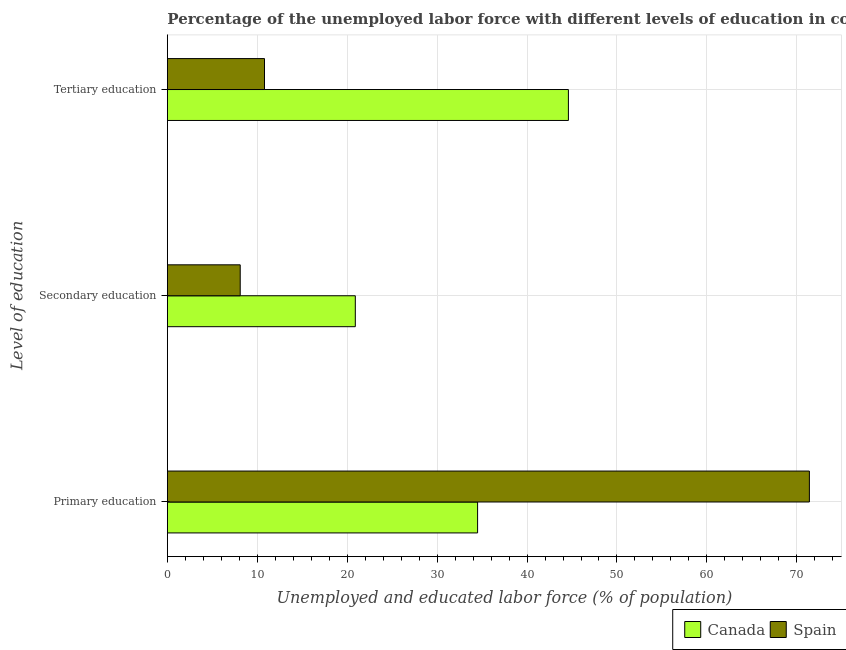Are the number of bars per tick equal to the number of legend labels?
Your answer should be compact. Yes. Are the number of bars on each tick of the Y-axis equal?
Provide a short and direct response. Yes. What is the label of the 2nd group of bars from the top?
Give a very brief answer. Secondary education. What is the percentage of labor force who received secondary education in Canada?
Your answer should be very brief. 20.9. Across all countries, what is the maximum percentage of labor force who received primary education?
Your response must be concise. 71.4. Across all countries, what is the minimum percentage of labor force who received primary education?
Provide a succinct answer. 34.5. In which country was the percentage of labor force who received tertiary education maximum?
Give a very brief answer. Canada. In which country was the percentage of labor force who received secondary education minimum?
Provide a short and direct response. Spain. What is the total percentage of labor force who received secondary education in the graph?
Ensure brevity in your answer.  29. What is the difference between the percentage of labor force who received primary education in Spain and that in Canada?
Your answer should be very brief. 36.9. What is the difference between the percentage of labor force who received secondary education in Spain and the percentage of labor force who received tertiary education in Canada?
Provide a succinct answer. -36.5. What is the average percentage of labor force who received tertiary education per country?
Provide a short and direct response. 27.7. What is the difference between the percentage of labor force who received secondary education and percentage of labor force who received tertiary education in Spain?
Your answer should be very brief. -2.7. What is the ratio of the percentage of labor force who received primary education in Canada to that in Spain?
Offer a terse response. 0.48. What is the difference between the highest and the second highest percentage of labor force who received secondary education?
Offer a very short reply. 12.8. What is the difference between the highest and the lowest percentage of labor force who received tertiary education?
Your response must be concise. 33.8. In how many countries, is the percentage of labor force who received secondary education greater than the average percentage of labor force who received secondary education taken over all countries?
Provide a short and direct response. 1. Is the sum of the percentage of labor force who received primary education in Spain and Canada greater than the maximum percentage of labor force who received tertiary education across all countries?
Your answer should be very brief. Yes. What does the 2nd bar from the bottom in Primary education represents?
Provide a succinct answer. Spain. How many bars are there?
Offer a terse response. 6. How many countries are there in the graph?
Provide a succinct answer. 2. Are the values on the major ticks of X-axis written in scientific E-notation?
Provide a succinct answer. No. Does the graph contain grids?
Your response must be concise. Yes. Where does the legend appear in the graph?
Ensure brevity in your answer.  Bottom right. How many legend labels are there?
Your answer should be very brief. 2. What is the title of the graph?
Offer a very short reply. Percentage of the unemployed labor force with different levels of education in countries. Does "Netherlands" appear as one of the legend labels in the graph?
Keep it short and to the point. No. What is the label or title of the X-axis?
Your answer should be compact. Unemployed and educated labor force (% of population). What is the label or title of the Y-axis?
Ensure brevity in your answer.  Level of education. What is the Unemployed and educated labor force (% of population) of Canada in Primary education?
Your answer should be very brief. 34.5. What is the Unemployed and educated labor force (% of population) in Spain in Primary education?
Give a very brief answer. 71.4. What is the Unemployed and educated labor force (% of population) of Canada in Secondary education?
Your answer should be very brief. 20.9. What is the Unemployed and educated labor force (% of population) of Spain in Secondary education?
Your answer should be very brief. 8.1. What is the Unemployed and educated labor force (% of population) in Canada in Tertiary education?
Give a very brief answer. 44.6. What is the Unemployed and educated labor force (% of population) of Spain in Tertiary education?
Make the answer very short. 10.8. Across all Level of education, what is the maximum Unemployed and educated labor force (% of population) of Canada?
Keep it short and to the point. 44.6. Across all Level of education, what is the maximum Unemployed and educated labor force (% of population) in Spain?
Give a very brief answer. 71.4. Across all Level of education, what is the minimum Unemployed and educated labor force (% of population) of Canada?
Give a very brief answer. 20.9. Across all Level of education, what is the minimum Unemployed and educated labor force (% of population) in Spain?
Provide a short and direct response. 8.1. What is the total Unemployed and educated labor force (% of population) of Canada in the graph?
Offer a very short reply. 100. What is the total Unemployed and educated labor force (% of population) of Spain in the graph?
Give a very brief answer. 90.3. What is the difference between the Unemployed and educated labor force (% of population) in Canada in Primary education and that in Secondary education?
Your answer should be compact. 13.6. What is the difference between the Unemployed and educated labor force (% of population) in Spain in Primary education and that in Secondary education?
Keep it short and to the point. 63.3. What is the difference between the Unemployed and educated labor force (% of population) in Spain in Primary education and that in Tertiary education?
Keep it short and to the point. 60.6. What is the difference between the Unemployed and educated labor force (% of population) of Canada in Secondary education and that in Tertiary education?
Your answer should be compact. -23.7. What is the difference between the Unemployed and educated labor force (% of population) of Canada in Primary education and the Unemployed and educated labor force (% of population) of Spain in Secondary education?
Your answer should be compact. 26.4. What is the difference between the Unemployed and educated labor force (% of population) in Canada in Primary education and the Unemployed and educated labor force (% of population) in Spain in Tertiary education?
Your answer should be very brief. 23.7. What is the average Unemployed and educated labor force (% of population) of Canada per Level of education?
Keep it short and to the point. 33.33. What is the average Unemployed and educated labor force (% of population) of Spain per Level of education?
Give a very brief answer. 30.1. What is the difference between the Unemployed and educated labor force (% of population) in Canada and Unemployed and educated labor force (% of population) in Spain in Primary education?
Your answer should be very brief. -36.9. What is the difference between the Unemployed and educated labor force (% of population) in Canada and Unemployed and educated labor force (% of population) in Spain in Secondary education?
Keep it short and to the point. 12.8. What is the difference between the Unemployed and educated labor force (% of population) in Canada and Unemployed and educated labor force (% of population) in Spain in Tertiary education?
Your answer should be very brief. 33.8. What is the ratio of the Unemployed and educated labor force (% of population) in Canada in Primary education to that in Secondary education?
Ensure brevity in your answer.  1.65. What is the ratio of the Unemployed and educated labor force (% of population) of Spain in Primary education to that in Secondary education?
Ensure brevity in your answer.  8.81. What is the ratio of the Unemployed and educated labor force (% of population) in Canada in Primary education to that in Tertiary education?
Provide a short and direct response. 0.77. What is the ratio of the Unemployed and educated labor force (% of population) in Spain in Primary education to that in Tertiary education?
Give a very brief answer. 6.61. What is the ratio of the Unemployed and educated labor force (% of population) in Canada in Secondary education to that in Tertiary education?
Provide a short and direct response. 0.47. What is the difference between the highest and the second highest Unemployed and educated labor force (% of population) in Spain?
Offer a terse response. 60.6. What is the difference between the highest and the lowest Unemployed and educated labor force (% of population) of Canada?
Offer a very short reply. 23.7. What is the difference between the highest and the lowest Unemployed and educated labor force (% of population) in Spain?
Give a very brief answer. 63.3. 